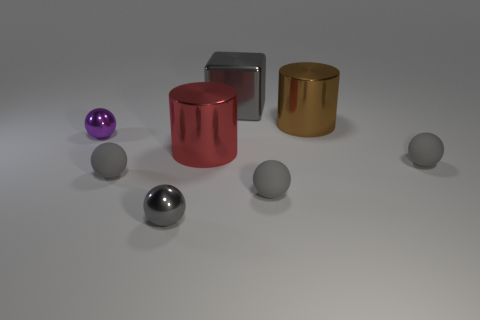Does the small purple object have the same shape as the big gray thing?
Your response must be concise. No. What number of big metal cylinders have the same color as the big cube?
Ensure brevity in your answer.  0. Does the shiny sphere behind the red object have the same color as the rubber thing that is to the left of the gray metal ball?
Your answer should be compact. No. There is a gray metal ball; are there any purple metal balls in front of it?
Provide a short and direct response. No. What material is the small purple thing?
Your answer should be very brief. Metal. There is a small rubber thing right of the big brown metallic cylinder; what shape is it?
Make the answer very short. Sphere. There is a metal sphere that is the same color as the large block; what is its size?
Your answer should be very brief. Small. Are there any brown cylinders of the same size as the red shiny thing?
Offer a very short reply. Yes. Are the small gray thing to the left of the tiny gray metal ball and the purple sphere made of the same material?
Offer a terse response. No. Are there an equal number of large gray cubes in front of the large red object and large cubes right of the metallic cube?
Your response must be concise. Yes. 